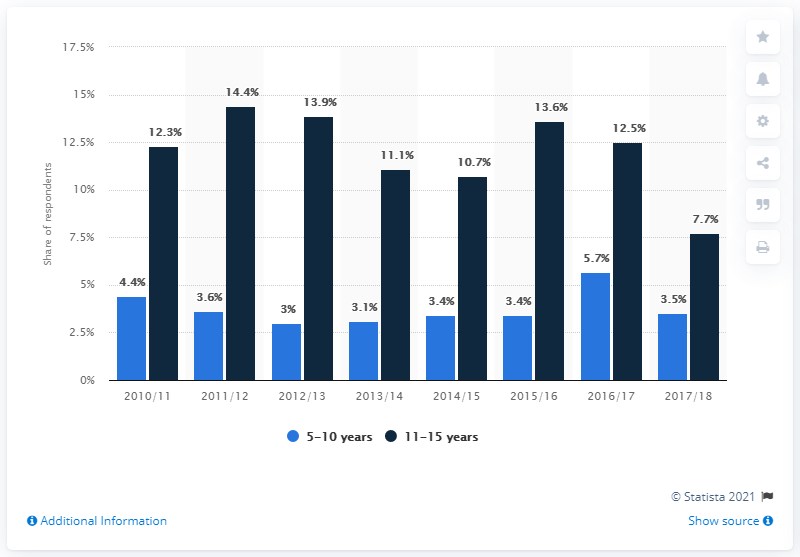Highlight a few significant elements in this photo. In 2017-2018, there was a difference of 4.2 units between navy blue and light blue bars. The highest number of respondents in light blue is 5.7. 